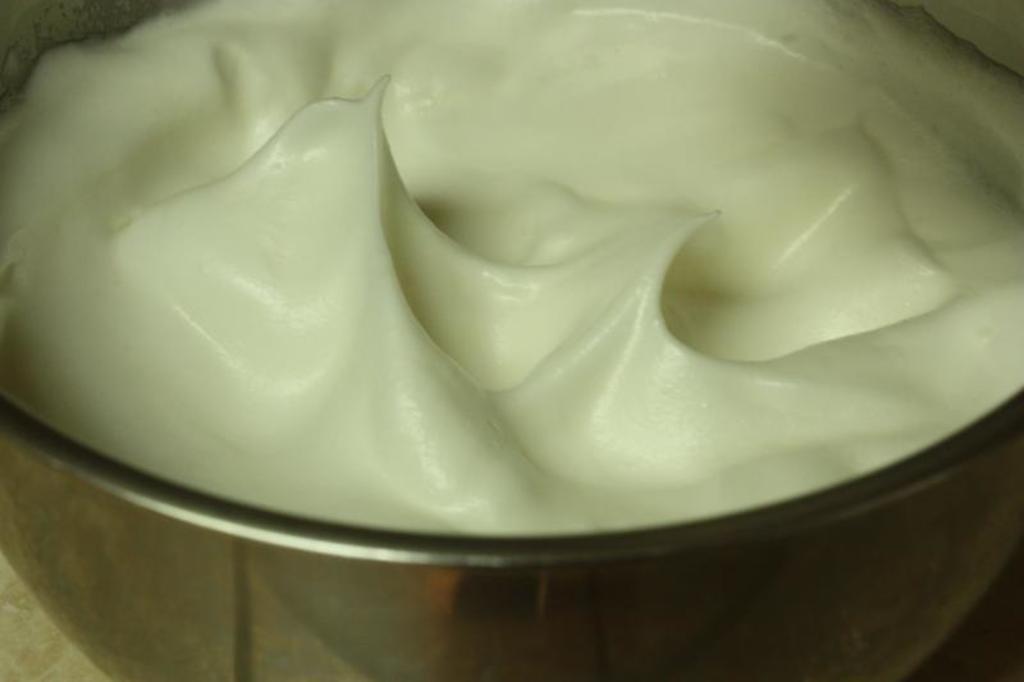In one or two sentences, can you explain what this image depicts? In this image there is like a cream in a bowl. 